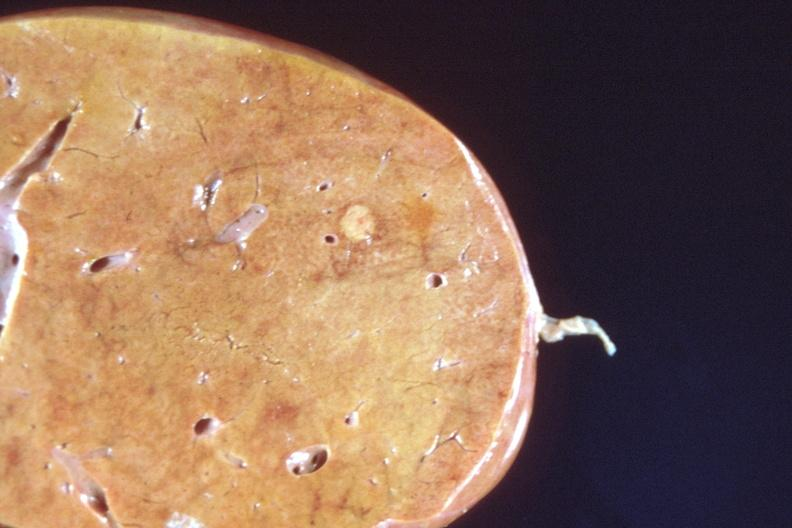does fallopian tube show liver, metastatic breast cancer?
Answer the question using a single word or phrase. No 